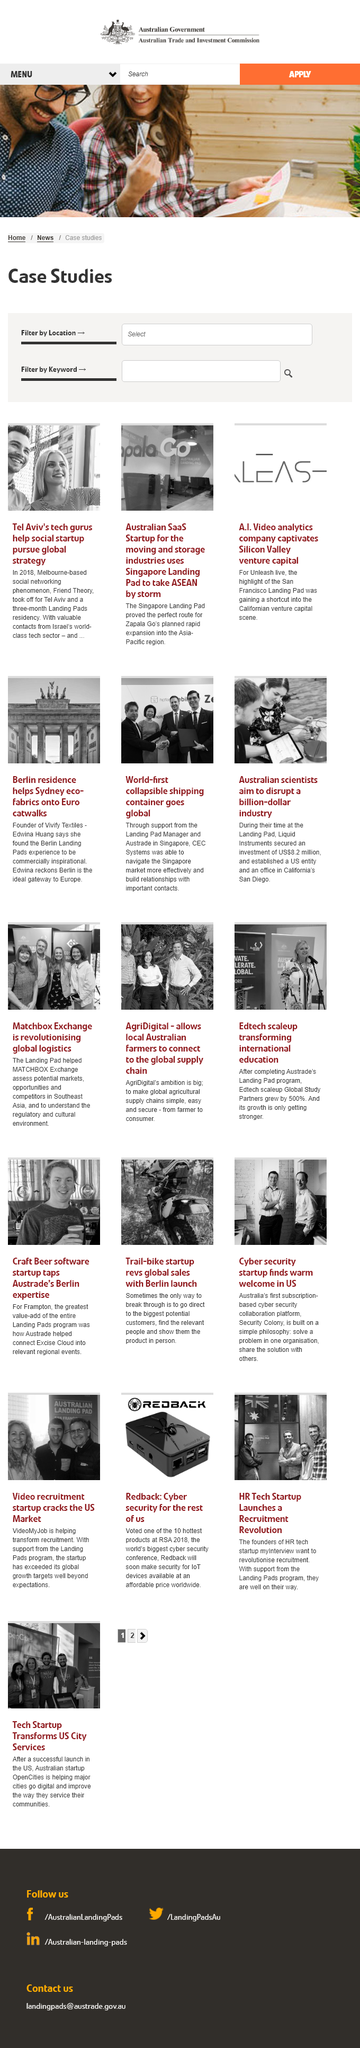List a handful of essential elements in this visual. According to Edwina, the ideal gateway to Europe is Berlin. Landing Pad has collaborated with companies such as Vivify Textiles, CEC Systems, and Liquid Instruments. Liquid Instruments established an office in San Diego, California. 